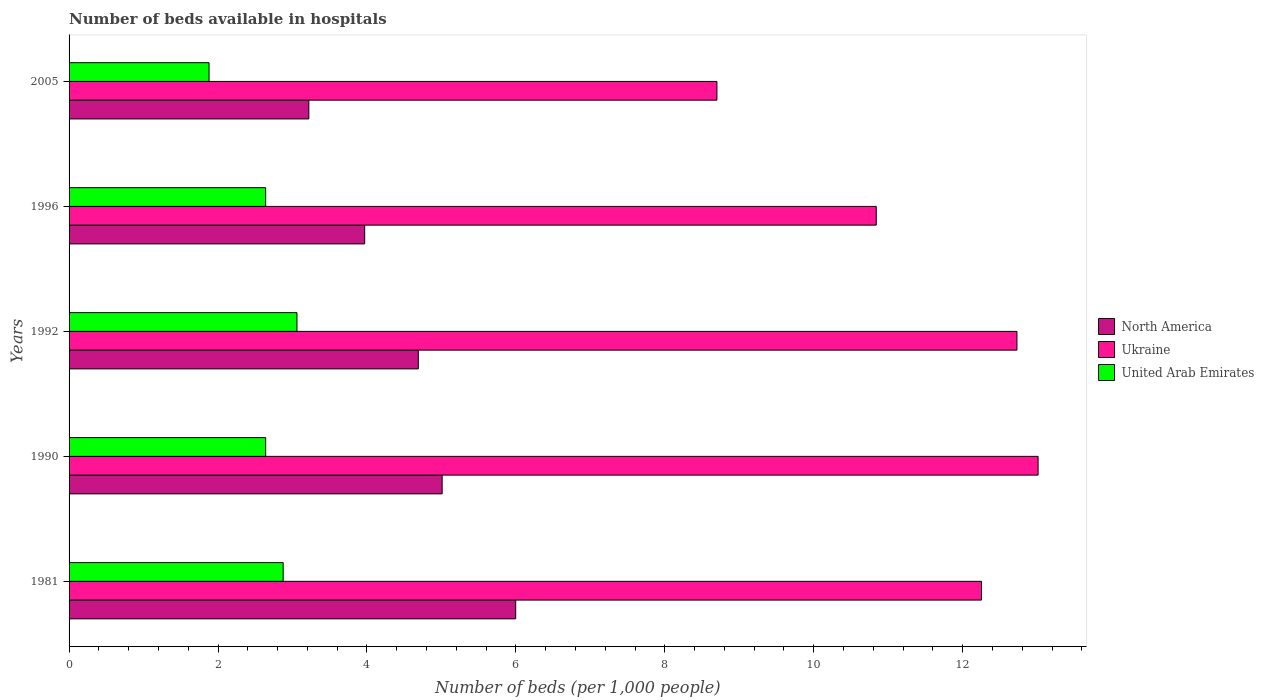How many different coloured bars are there?
Your answer should be very brief. 3. How many groups of bars are there?
Offer a very short reply. 5. Are the number of bars per tick equal to the number of legend labels?
Your answer should be very brief. Yes. Are the number of bars on each tick of the Y-axis equal?
Provide a succinct answer. Yes. How many bars are there on the 3rd tick from the top?
Your answer should be very brief. 3. What is the label of the 3rd group of bars from the top?
Provide a short and direct response. 1992. In how many cases, is the number of bars for a given year not equal to the number of legend labels?
Give a very brief answer. 0. What is the number of beds in the hospiatls of in Ukraine in 1981?
Give a very brief answer. 12.25. Across all years, what is the maximum number of beds in the hospiatls of in North America?
Make the answer very short. 6. Across all years, what is the minimum number of beds in the hospiatls of in North America?
Your answer should be very brief. 3.22. In which year was the number of beds in the hospiatls of in Ukraine minimum?
Make the answer very short. 2005. What is the total number of beds in the hospiatls of in North America in the graph?
Ensure brevity in your answer.  22.89. What is the difference between the number of beds in the hospiatls of in United Arab Emirates in 1981 and that in 1996?
Your answer should be compact. 0.24. What is the difference between the number of beds in the hospiatls of in North America in 1992 and the number of beds in the hospiatls of in United Arab Emirates in 1996?
Provide a succinct answer. 2.05. What is the average number of beds in the hospiatls of in Ukraine per year?
Your response must be concise. 11.51. In the year 1996, what is the difference between the number of beds in the hospiatls of in Ukraine and number of beds in the hospiatls of in United Arab Emirates?
Make the answer very short. 8.2. What is the ratio of the number of beds in the hospiatls of in North America in 1990 to that in 2005?
Make the answer very short. 1.56. Is the number of beds in the hospiatls of in United Arab Emirates in 1981 less than that in 2005?
Keep it short and to the point. No. What is the difference between the highest and the second highest number of beds in the hospiatls of in North America?
Ensure brevity in your answer.  0.99. What is the difference between the highest and the lowest number of beds in the hospiatls of in Ukraine?
Provide a succinct answer. 4.31. In how many years, is the number of beds in the hospiatls of in United Arab Emirates greater than the average number of beds in the hospiatls of in United Arab Emirates taken over all years?
Offer a very short reply. 4. What does the 1st bar from the top in 1996 represents?
Offer a terse response. United Arab Emirates. What does the 2nd bar from the bottom in 1992 represents?
Your answer should be very brief. Ukraine. Are all the bars in the graph horizontal?
Provide a short and direct response. Yes. Does the graph contain grids?
Provide a short and direct response. No. How many legend labels are there?
Ensure brevity in your answer.  3. How are the legend labels stacked?
Your answer should be very brief. Vertical. What is the title of the graph?
Give a very brief answer. Number of beds available in hospitals. What is the label or title of the X-axis?
Your answer should be compact. Number of beds (per 1,0 people). What is the label or title of the Y-axis?
Your response must be concise. Years. What is the Number of beds (per 1,000 people) of North America in 1981?
Provide a short and direct response. 6. What is the Number of beds (per 1,000 people) in Ukraine in 1981?
Make the answer very short. 12.25. What is the Number of beds (per 1,000 people) in United Arab Emirates in 1981?
Your answer should be compact. 2.88. What is the Number of beds (per 1,000 people) in North America in 1990?
Offer a very short reply. 5.01. What is the Number of beds (per 1,000 people) in Ukraine in 1990?
Ensure brevity in your answer.  13.01. What is the Number of beds (per 1,000 people) in United Arab Emirates in 1990?
Your answer should be very brief. 2.64. What is the Number of beds (per 1,000 people) of North America in 1992?
Give a very brief answer. 4.69. What is the Number of beds (per 1,000 people) of Ukraine in 1992?
Your answer should be compact. 12.73. What is the Number of beds (per 1,000 people) in United Arab Emirates in 1992?
Provide a succinct answer. 3.06. What is the Number of beds (per 1,000 people) in North America in 1996?
Your answer should be very brief. 3.97. What is the Number of beds (per 1,000 people) in Ukraine in 1996?
Provide a succinct answer. 10.84. What is the Number of beds (per 1,000 people) of United Arab Emirates in 1996?
Your answer should be compact. 2.64. What is the Number of beds (per 1,000 people) in North America in 2005?
Keep it short and to the point. 3.22. What is the Number of beds (per 1,000 people) of United Arab Emirates in 2005?
Give a very brief answer. 1.88. Across all years, what is the maximum Number of beds (per 1,000 people) in North America?
Ensure brevity in your answer.  6. Across all years, what is the maximum Number of beds (per 1,000 people) in Ukraine?
Your answer should be very brief. 13.01. Across all years, what is the maximum Number of beds (per 1,000 people) in United Arab Emirates?
Offer a terse response. 3.06. Across all years, what is the minimum Number of beds (per 1,000 people) in North America?
Your answer should be very brief. 3.22. Across all years, what is the minimum Number of beds (per 1,000 people) of Ukraine?
Your response must be concise. 8.7. Across all years, what is the minimum Number of beds (per 1,000 people) of United Arab Emirates?
Your answer should be very brief. 1.88. What is the total Number of beds (per 1,000 people) in North America in the graph?
Keep it short and to the point. 22.89. What is the total Number of beds (per 1,000 people) of Ukraine in the graph?
Offer a very short reply. 57.54. What is the total Number of beds (per 1,000 people) of United Arab Emirates in the graph?
Make the answer very short. 13.1. What is the difference between the Number of beds (per 1,000 people) of Ukraine in 1981 and that in 1990?
Ensure brevity in your answer.  -0.76. What is the difference between the Number of beds (per 1,000 people) in United Arab Emirates in 1981 and that in 1990?
Make the answer very short. 0.24. What is the difference between the Number of beds (per 1,000 people) in North America in 1981 and that in 1992?
Offer a very short reply. 1.31. What is the difference between the Number of beds (per 1,000 people) in Ukraine in 1981 and that in 1992?
Offer a very short reply. -0.48. What is the difference between the Number of beds (per 1,000 people) of United Arab Emirates in 1981 and that in 1992?
Keep it short and to the point. -0.19. What is the difference between the Number of beds (per 1,000 people) of North America in 1981 and that in 1996?
Make the answer very short. 2.03. What is the difference between the Number of beds (per 1,000 people) in Ukraine in 1981 and that in 1996?
Make the answer very short. 1.41. What is the difference between the Number of beds (per 1,000 people) of United Arab Emirates in 1981 and that in 1996?
Offer a very short reply. 0.24. What is the difference between the Number of beds (per 1,000 people) of North America in 1981 and that in 2005?
Provide a short and direct response. 2.78. What is the difference between the Number of beds (per 1,000 people) in Ukraine in 1981 and that in 2005?
Offer a very short reply. 3.55. What is the difference between the Number of beds (per 1,000 people) of United Arab Emirates in 1981 and that in 2005?
Offer a terse response. 1. What is the difference between the Number of beds (per 1,000 people) in North America in 1990 and that in 1992?
Ensure brevity in your answer.  0.32. What is the difference between the Number of beds (per 1,000 people) of Ukraine in 1990 and that in 1992?
Make the answer very short. 0.28. What is the difference between the Number of beds (per 1,000 people) in United Arab Emirates in 1990 and that in 1992?
Your answer should be very brief. -0.42. What is the difference between the Number of beds (per 1,000 people) in North America in 1990 and that in 1996?
Make the answer very short. 1.04. What is the difference between the Number of beds (per 1,000 people) in Ukraine in 1990 and that in 1996?
Make the answer very short. 2.17. What is the difference between the Number of beds (per 1,000 people) in North America in 1990 and that in 2005?
Offer a terse response. 1.79. What is the difference between the Number of beds (per 1,000 people) of Ukraine in 1990 and that in 2005?
Give a very brief answer. 4.31. What is the difference between the Number of beds (per 1,000 people) in United Arab Emirates in 1990 and that in 2005?
Your answer should be very brief. 0.76. What is the difference between the Number of beds (per 1,000 people) in North America in 1992 and that in 1996?
Make the answer very short. 0.72. What is the difference between the Number of beds (per 1,000 people) in Ukraine in 1992 and that in 1996?
Your answer should be very brief. 1.89. What is the difference between the Number of beds (per 1,000 people) in United Arab Emirates in 1992 and that in 1996?
Provide a short and direct response. 0.42. What is the difference between the Number of beds (per 1,000 people) of North America in 1992 and that in 2005?
Provide a short and direct response. 1.47. What is the difference between the Number of beds (per 1,000 people) of Ukraine in 1992 and that in 2005?
Offer a very short reply. 4.03. What is the difference between the Number of beds (per 1,000 people) of United Arab Emirates in 1992 and that in 2005?
Give a very brief answer. 1.18. What is the difference between the Number of beds (per 1,000 people) in North America in 1996 and that in 2005?
Give a very brief answer. 0.75. What is the difference between the Number of beds (per 1,000 people) in Ukraine in 1996 and that in 2005?
Provide a short and direct response. 2.14. What is the difference between the Number of beds (per 1,000 people) in United Arab Emirates in 1996 and that in 2005?
Keep it short and to the point. 0.76. What is the difference between the Number of beds (per 1,000 people) of North America in 1981 and the Number of beds (per 1,000 people) of Ukraine in 1990?
Offer a terse response. -7.02. What is the difference between the Number of beds (per 1,000 people) in North America in 1981 and the Number of beds (per 1,000 people) in United Arab Emirates in 1990?
Make the answer very short. 3.36. What is the difference between the Number of beds (per 1,000 people) in Ukraine in 1981 and the Number of beds (per 1,000 people) in United Arab Emirates in 1990?
Ensure brevity in your answer.  9.61. What is the difference between the Number of beds (per 1,000 people) in North America in 1981 and the Number of beds (per 1,000 people) in Ukraine in 1992?
Offer a terse response. -6.73. What is the difference between the Number of beds (per 1,000 people) of North America in 1981 and the Number of beds (per 1,000 people) of United Arab Emirates in 1992?
Make the answer very short. 2.94. What is the difference between the Number of beds (per 1,000 people) of Ukraine in 1981 and the Number of beds (per 1,000 people) of United Arab Emirates in 1992?
Your answer should be very brief. 9.19. What is the difference between the Number of beds (per 1,000 people) of North America in 1981 and the Number of beds (per 1,000 people) of Ukraine in 1996?
Provide a succinct answer. -4.84. What is the difference between the Number of beds (per 1,000 people) in North America in 1981 and the Number of beds (per 1,000 people) in United Arab Emirates in 1996?
Provide a short and direct response. 3.36. What is the difference between the Number of beds (per 1,000 people) in Ukraine in 1981 and the Number of beds (per 1,000 people) in United Arab Emirates in 1996?
Your response must be concise. 9.61. What is the difference between the Number of beds (per 1,000 people) in North America in 1981 and the Number of beds (per 1,000 people) in Ukraine in 2005?
Your response must be concise. -2.7. What is the difference between the Number of beds (per 1,000 people) of North America in 1981 and the Number of beds (per 1,000 people) of United Arab Emirates in 2005?
Make the answer very short. 4.12. What is the difference between the Number of beds (per 1,000 people) in Ukraine in 1981 and the Number of beds (per 1,000 people) in United Arab Emirates in 2005?
Offer a terse response. 10.37. What is the difference between the Number of beds (per 1,000 people) of North America in 1990 and the Number of beds (per 1,000 people) of Ukraine in 1992?
Provide a short and direct response. -7.72. What is the difference between the Number of beds (per 1,000 people) in North America in 1990 and the Number of beds (per 1,000 people) in United Arab Emirates in 1992?
Offer a terse response. 1.95. What is the difference between the Number of beds (per 1,000 people) of Ukraine in 1990 and the Number of beds (per 1,000 people) of United Arab Emirates in 1992?
Keep it short and to the point. 9.95. What is the difference between the Number of beds (per 1,000 people) of North America in 1990 and the Number of beds (per 1,000 people) of Ukraine in 1996?
Your response must be concise. -5.83. What is the difference between the Number of beds (per 1,000 people) of North America in 1990 and the Number of beds (per 1,000 people) of United Arab Emirates in 1996?
Offer a very short reply. 2.37. What is the difference between the Number of beds (per 1,000 people) of Ukraine in 1990 and the Number of beds (per 1,000 people) of United Arab Emirates in 1996?
Your response must be concise. 10.37. What is the difference between the Number of beds (per 1,000 people) of North America in 1990 and the Number of beds (per 1,000 people) of Ukraine in 2005?
Offer a very short reply. -3.69. What is the difference between the Number of beds (per 1,000 people) of North America in 1990 and the Number of beds (per 1,000 people) of United Arab Emirates in 2005?
Your answer should be compact. 3.13. What is the difference between the Number of beds (per 1,000 people) of Ukraine in 1990 and the Number of beds (per 1,000 people) of United Arab Emirates in 2005?
Ensure brevity in your answer.  11.13. What is the difference between the Number of beds (per 1,000 people) in North America in 1992 and the Number of beds (per 1,000 people) in Ukraine in 1996?
Ensure brevity in your answer.  -6.15. What is the difference between the Number of beds (per 1,000 people) in North America in 1992 and the Number of beds (per 1,000 people) in United Arab Emirates in 1996?
Provide a short and direct response. 2.05. What is the difference between the Number of beds (per 1,000 people) of Ukraine in 1992 and the Number of beds (per 1,000 people) of United Arab Emirates in 1996?
Provide a short and direct response. 10.09. What is the difference between the Number of beds (per 1,000 people) of North America in 1992 and the Number of beds (per 1,000 people) of Ukraine in 2005?
Your answer should be very brief. -4.01. What is the difference between the Number of beds (per 1,000 people) of North America in 1992 and the Number of beds (per 1,000 people) of United Arab Emirates in 2005?
Make the answer very short. 2.81. What is the difference between the Number of beds (per 1,000 people) of Ukraine in 1992 and the Number of beds (per 1,000 people) of United Arab Emirates in 2005?
Offer a terse response. 10.85. What is the difference between the Number of beds (per 1,000 people) of North America in 1996 and the Number of beds (per 1,000 people) of Ukraine in 2005?
Offer a terse response. -4.73. What is the difference between the Number of beds (per 1,000 people) of North America in 1996 and the Number of beds (per 1,000 people) of United Arab Emirates in 2005?
Your response must be concise. 2.09. What is the difference between the Number of beds (per 1,000 people) in Ukraine in 1996 and the Number of beds (per 1,000 people) in United Arab Emirates in 2005?
Provide a short and direct response. 8.96. What is the average Number of beds (per 1,000 people) of North America per year?
Your answer should be very brief. 4.58. What is the average Number of beds (per 1,000 people) in Ukraine per year?
Make the answer very short. 11.51. What is the average Number of beds (per 1,000 people) in United Arab Emirates per year?
Your answer should be very brief. 2.62. In the year 1981, what is the difference between the Number of beds (per 1,000 people) of North America and Number of beds (per 1,000 people) of Ukraine?
Ensure brevity in your answer.  -6.26. In the year 1981, what is the difference between the Number of beds (per 1,000 people) of North America and Number of beds (per 1,000 people) of United Arab Emirates?
Offer a terse response. 3.12. In the year 1981, what is the difference between the Number of beds (per 1,000 people) of Ukraine and Number of beds (per 1,000 people) of United Arab Emirates?
Provide a succinct answer. 9.38. In the year 1990, what is the difference between the Number of beds (per 1,000 people) of North America and Number of beds (per 1,000 people) of Ukraine?
Your answer should be very brief. -8. In the year 1990, what is the difference between the Number of beds (per 1,000 people) of North America and Number of beds (per 1,000 people) of United Arab Emirates?
Your response must be concise. 2.37. In the year 1990, what is the difference between the Number of beds (per 1,000 people) of Ukraine and Number of beds (per 1,000 people) of United Arab Emirates?
Your answer should be very brief. 10.37. In the year 1992, what is the difference between the Number of beds (per 1,000 people) in North America and Number of beds (per 1,000 people) in Ukraine?
Your answer should be compact. -8.04. In the year 1992, what is the difference between the Number of beds (per 1,000 people) in North America and Number of beds (per 1,000 people) in United Arab Emirates?
Give a very brief answer. 1.63. In the year 1992, what is the difference between the Number of beds (per 1,000 people) in Ukraine and Number of beds (per 1,000 people) in United Arab Emirates?
Your answer should be very brief. 9.67. In the year 1996, what is the difference between the Number of beds (per 1,000 people) in North America and Number of beds (per 1,000 people) in Ukraine?
Make the answer very short. -6.87. In the year 1996, what is the difference between the Number of beds (per 1,000 people) of North America and Number of beds (per 1,000 people) of United Arab Emirates?
Provide a short and direct response. 1.33. In the year 2005, what is the difference between the Number of beds (per 1,000 people) of North America and Number of beds (per 1,000 people) of Ukraine?
Your answer should be very brief. -5.48. In the year 2005, what is the difference between the Number of beds (per 1,000 people) in North America and Number of beds (per 1,000 people) in United Arab Emirates?
Offer a very short reply. 1.34. In the year 2005, what is the difference between the Number of beds (per 1,000 people) in Ukraine and Number of beds (per 1,000 people) in United Arab Emirates?
Your answer should be compact. 6.82. What is the ratio of the Number of beds (per 1,000 people) of North America in 1981 to that in 1990?
Keep it short and to the point. 1.2. What is the ratio of the Number of beds (per 1,000 people) in Ukraine in 1981 to that in 1990?
Offer a very short reply. 0.94. What is the ratio of the Number of beds (per 1,000 people) of United Arab Emirates in 1981 to that in 1990?
Your answer should be very brief. 1.09. What is the ratio of the Number of beds (per 1,000 people) in North America in 1981 to that in 1992?
Offer a very short reply. 1.28. What is the ratio of the Number of beds (per 1,000 people) in Ukraine in 1981 to that in 1992?
Offer a terse response. 0.96. What is the ratio of the Number of beds (per 1,000 people) of United Arab Emirates in 1981 to that in 1992?
Provide a short and direct response. 0.94. What is the ratio of the Number of beds (per 1,000 people) of North America in 1981 to that in 1996?
Offer a very short reply. 1.51. What is the ratio of the Number of beds (per 1,000 people) in Ukraine in 1981 to that in 1996?
Ensure brevity in your answer.  1.13. What is the ratio of the Number of beds (per 1,000 people) of United Arab Emirates in 1981 to that in 1996?
Your answer should be compact. 1.09. What is the ratio of the Number of beds (per 1,000 people) in North America in 1981 to that in 2005?
Keep it short and to the point. 1.86. What is the ratio of the Number of beds (per 1,000 people) in Ukraine in 1981 to that in 2005?
Offer a terse response. 1.41. What is the ratio of the Number of beds (per 1,000 people) of United Arab Emirates in 1981 to that in 2005?
Offer a terse response. 1.53. What is the ratio of the Number of beds (per 1,000 people) of North America in 1990 to that in 1992?
Your response must be concise. 1.07. What is the ratio of the Number of beds (per 1,000 people) in Ukraine in 1990 to that in 1992?
Ensure brevity in your answer.  1.02. What is the ratio of the Number of beds (per 1,000 people) in United Arab Emirates in 1990 to that in 1992?
Your response must be concise. 0.86. What is the ratio of the Number of beds (per 1,000 people) of North America in 1990 to that in 1996?
Offer a terse response. 1.26. What is the ratio of the Number of beds (per 1,000 people) of Ukraine in 1990 to that in 1996?
Your response must be concise. 1.2. What is the ratio of the Number of beds (per 1,000 people) of North America in 1990 to that in 2005?
Ensure brevity in your answer.  1.56. What is the ratio of the Number of beds (per 1,000 people) of Ukraine in 1990 to that in 2005?
Give a very brief answer. 1.5. What is the ratio of the Number of beds (per 1,000 people) in United Arab Emirates in 1990 to that in 2005?
Your answer should be very brief. 1.4. What is the ratio of the Number of beds (per 1,000 people) of North America in 1992 to that in 1996?
Your response must be concise. 1.18. What is the ratio of the Number of beds (per 1,000 people) of Ukraine in 1992 to that in 1996?
Your answer should be compact. 1.17. What is the ratio of the Number of beds (per 1,000 people) in United Arab Emirates in 1992 to that in 1996?
Keep it short and to the point. 1.16. What is the ratio of the Number of beds (per 1,000 people) in North America in 1992 to that in 2005?
Offer a very short reply. 1.46. What is the ratio of the Number of beds (per 1,000 people) in Ukraine in 1992 to that in 2005?
Keep it short and to the point. 1.46. What is the ratio of the Number of beds (per 1,000 people) in United Arab Emirates in 1992 to that in 2005?
Ensure brevity in your answer.  1.63. What is the ratio of the Number of beds (per 1,000 people) of North America in 1996 to that in 2005?
Offer a very short reply. 1.23. What is the ratio of the Number of beds (per 1,000 people) in Ukraine in 1996 to that in 2005?
Provide a short and direct response. 1.25. What is the ratio of the Number of beds (per 1,000 people) in United Arab Emirates in 1996 to that in 2005?
Provide a short and direct response. 1.4. What is the difference between the highest and the second highest Number of beds (per 1,000 people) of Ukraine?
Keep it short and to the point. 0.28. What is the difference between the highest and the second highest Number of beds (per 1,000 people) in United Arab Emirates?
Your response must be concise. 0.19. What is the difference between the highest and the lowest Number of beds (per 1,000 people) in North America?
Offer a very short reply. 2.78. What is the difference between the highest and the lowest Number of beds (per 1,000 people) of Ukraine?
Ensure brevity in your answer.  4.31. What is the difference between the highest and the lowest Number of beds (per 1,000 people) of United Arab Emirates?
Your answer should be very brief. 1.18. 